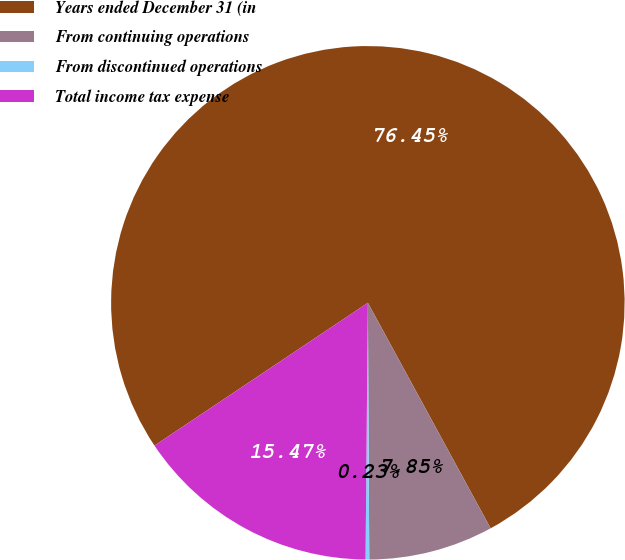<chart> <loc_0><loc_0><loc_500><loc_500><pie_chart><fcel>Years ended December 31 (in<fcel>From continuing operations<fcel>From discontinued operations<fcel>Total income tax expense<nl><fcel>76.45%<fcel>7.85%<fcel>0.23%<fcel>15.47%<nl></chart> 